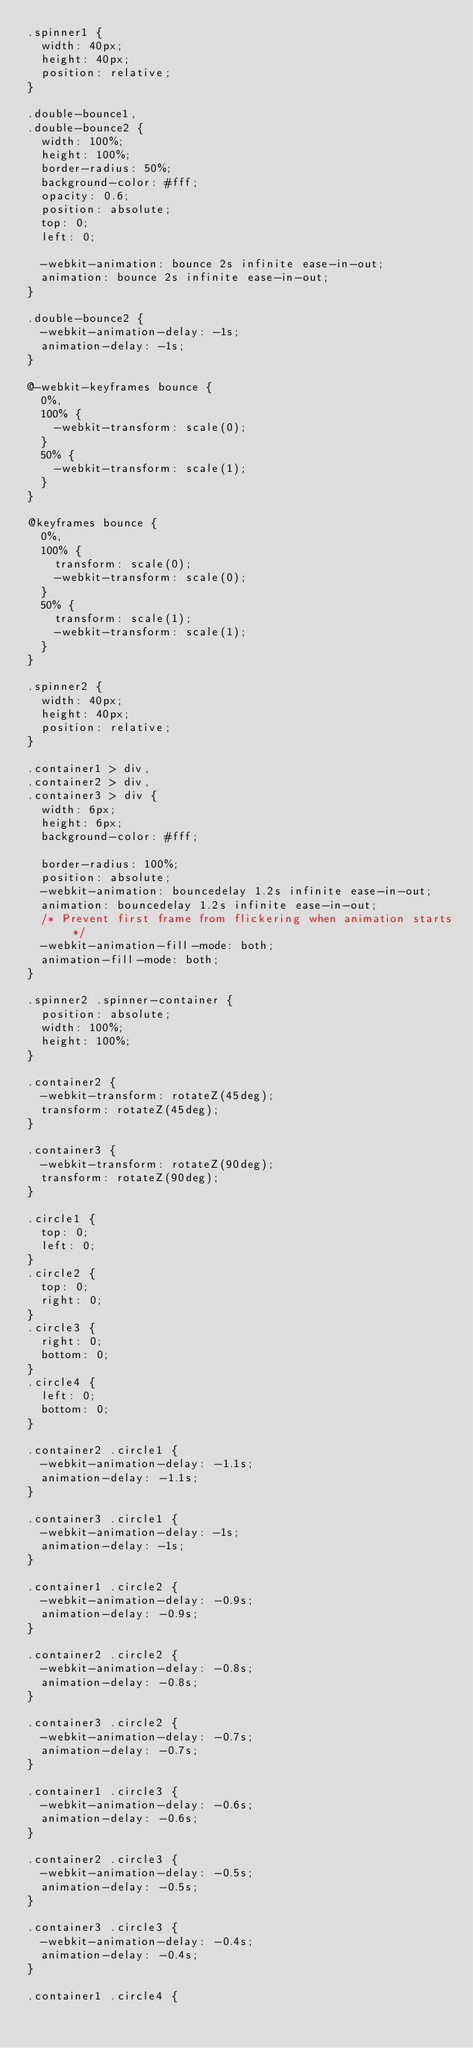Convert code to text. <code><loc_0><loc_0><loc_500><loc_500><_CSS_>.spinner1 {
  width: 40px;
  height: 40px;
  position: relative;
}

.double-bounce1,
.double-bounce2 {
  width: 100%;
  height: 100%;
  border-radius: 50%;
  background-color: #fff;
  opacity: 0.6;
  position: absolute;
  top: 0;
  left: 0;

  -webkit-animation: bounce 2s infinite ease-in-out;
  animation: bounce 2s infinite ease-in-out;
}

.double-bounce2 {
  -webkit-animation-delay: -1s;
  animation-delay: -1s;
}

@-webkit-keyframes bounce {
  0%,
  100% {
    -webkit-transform: scale(0);
  }
  50% {
    -webkit-transform: scale(1);
  }
}

@keyframes bounce {
  0%,
  100% {
    transform: scale(0);
    -webkit-transform: scale(0);
  }
  50% {
    transform: scale(1);
    -webkit-transform: scale(1);
  }
}

.spinner2 {
  width: 40px;
  height: 40px;
  position: relative;
}

.container1 > div,
.container2 > div,
.container3 > div {
  width: 6px;
  height: 6px;
  background-color: #fff;

  border-radius: 100%;
  position: absolute;
  -webkit-animation: bouncedelay 1.2s infinite ease-in-out;
  animation: bouncedelay 1.2s infinite ease-in-out;
  /* Prevent first frame from flickering when animation starts */
  -webkit-animation-fill-mode: both;
  animation-fill-mode: both;
}

.spinner2 .spinner-container {
  position: absolute;
  width: 100%;
  height: 100%;
}

.container2 {
  -webkit-transform: rotateZ(45deg);
  transform: rotateZ(45deg);
}

.container3 {
  -webkit-transform: rotateZ(90deg);
  transform: rotateZ(90deg);
}

.circle1 {
  top: 0;
  left: 0;
}
.circle2 {
  top: 0;
  right: 0;
}
.circle3 {
  right: 0;
  bottom: 0;
}
.circle4 {
  left: 0;
  bottom: 0;
}

.container2 .circle1 {
  -webkit-animation-delay: -1.1s;
  animation-delay: -1.1s;
}

.container3 .circle1 {
  -webkit-animation-delay: -1s;
  animation-delay: -1s;
}

.container1 .circle2 {
  -webkit-animation-delay: -0.9s;
  animation-delay: -0.9s;
}

.container2 .circle2 {
  -webkit-animation-delay: -0.8s;
  animation-delay: -0.8s;
}

.container3 .circle2 {
  -webkit-animation-delay: -0.7s;
  animation-delay: -0.7s;
}

.container1 .circle3 {
  -webkit-animation-delay: -0.6s;
  animation-delay: -0.6s;
}

.container2 .circle3 {
  -webkit-animation-delay: -0.5s;
  animation-delay: -0.5s;
}

.container3 .circle3 {
  -webkit-animation-delay: -0.4s;
  animation-delay: -0.4s;
}

.container1 .circle4 {</code> 